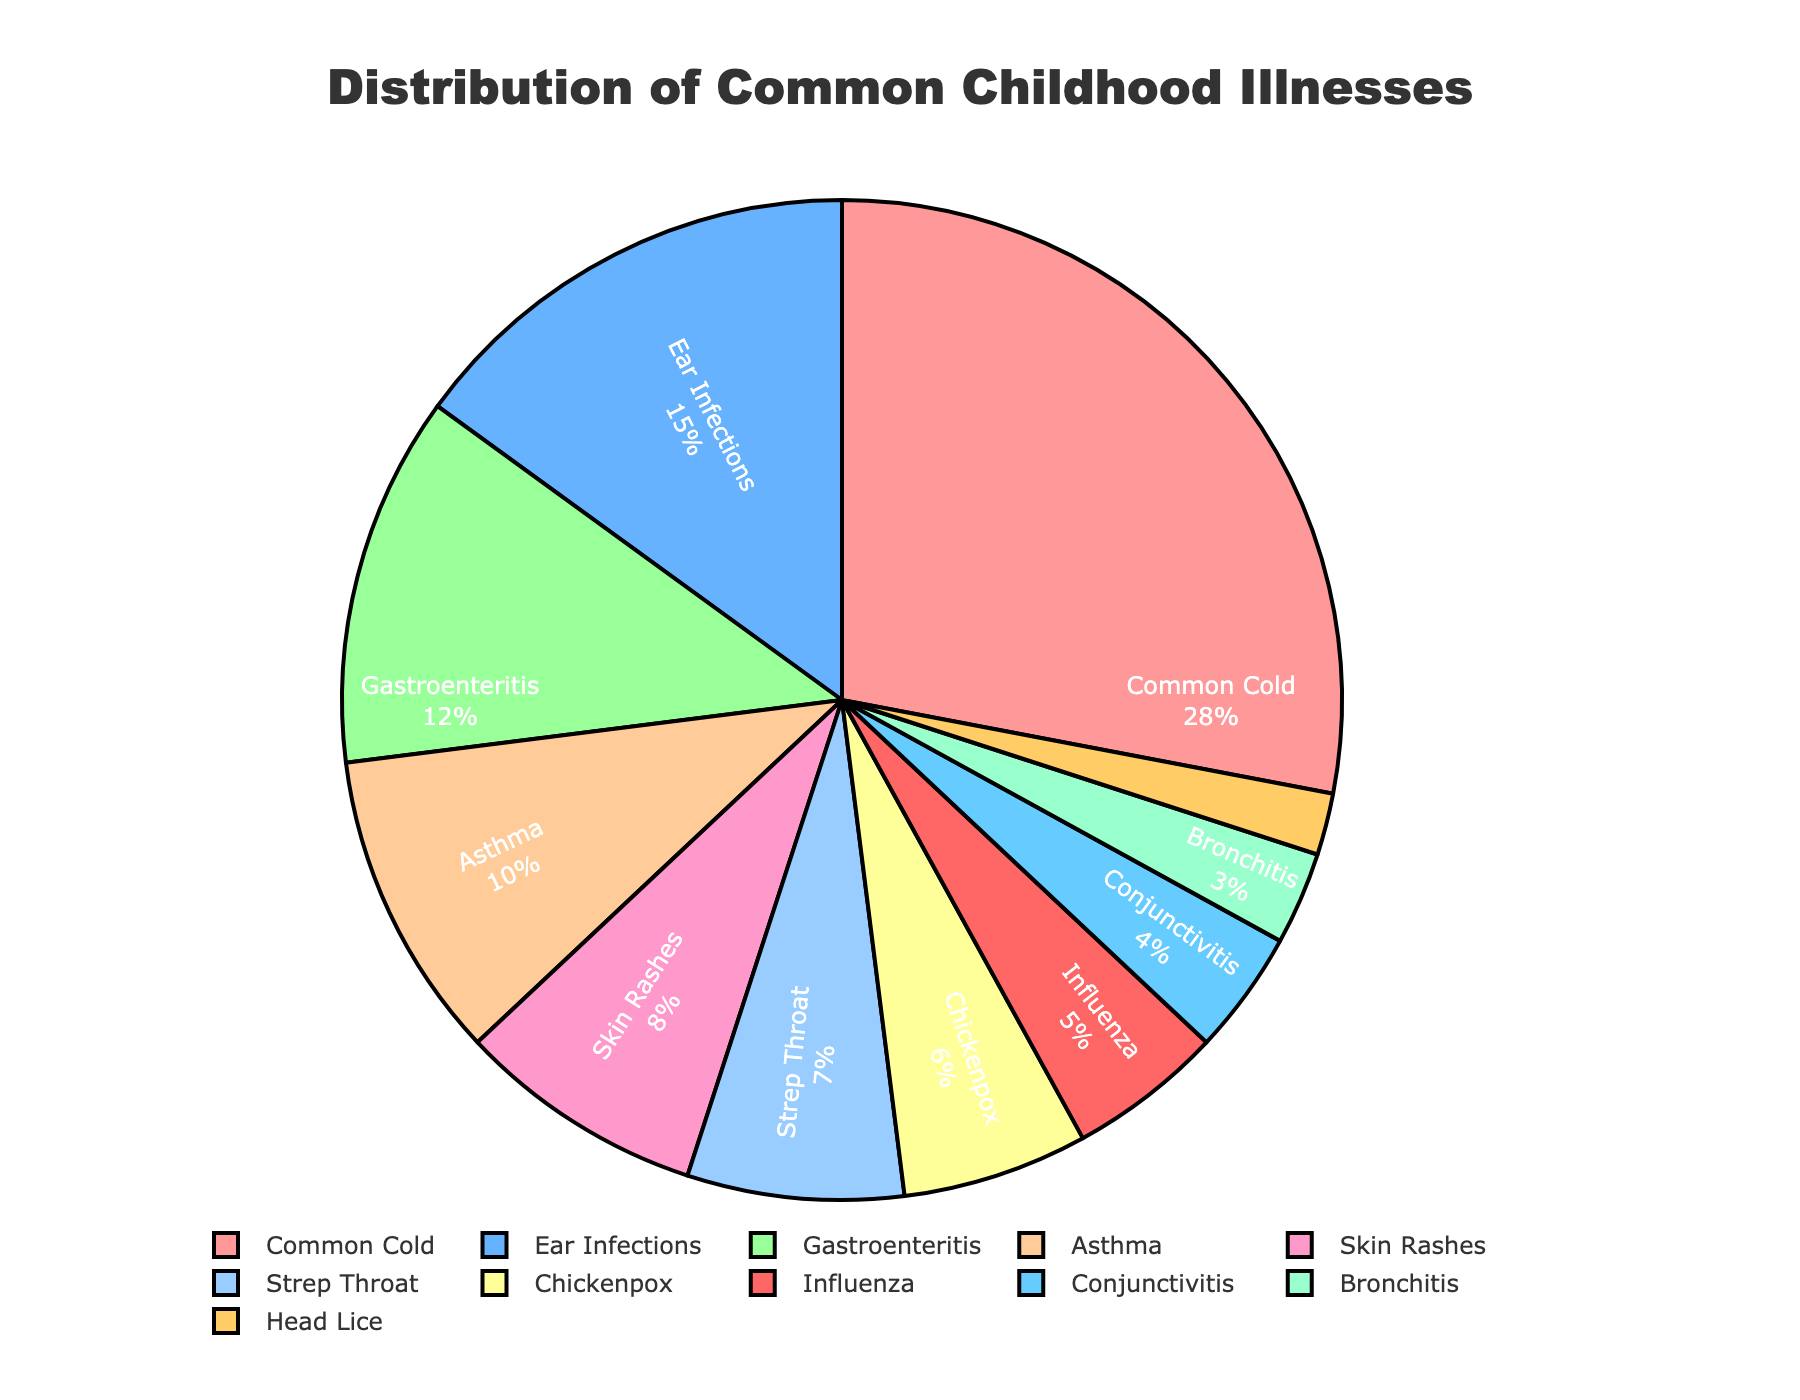what illness has the highest percentage? The figure shows that the "Common Cold" segment occupies the largest portion of the pie chart. This can be determined visually by comparing the sizes of the segments.
Answer: Common Cold Which illness is more common, Asthma or Chickenpox? By looking at the sizes of the segments labeled "Asthma" and "Chickenpox", the "Asthma" segment is larger than the "Chickenpox" segment.
Answer: Asthma What is the combined percentage of Gastroenteritis and Strep Throat? The figure shows the percentages for Gastroenteritis (12%) and Strep Throat (7%). Adding these percentages together gives 12% + 7% = 19%.
Answer: 19% Among the illnesses treated, which has the smallest percentage? The smallest segment on the pie chart corresponds to "Head Lice".
Answer: Head Lice How does the percentage of Influenza compare to that of Bronchitis? The figure shows that the percentage of Influenza (5%) is greater than that of Bronchitis (3%).
Answer: Influenza has a higher percentage What is the difference in percentage between Skin Rashes and Ear Infections? According to the figure, Skin Rashes account for 8% and Ear Infections for 15%. The difference is 15% - 8% = 7%.
Answer: 7% If you sum the percentages of Conjunctivitis, Bronchitis, and Head Lice, what do you get? The percentages are Conjunctivitis (4%), Bronchitis (3%), and Head Lice (2%). Summing them up: 4% + 3% + 2% = 9%.
Answer: 9% Which illness is represented by a green segment in the pie chart? The "Gastroenteritis" segment is colored green in the pie chart.
Answer: Gastroenteritis Are there more children treated for Ear Infections or for Strep Throat and Chickenpox combined? Ear Infections have a percentage of 15%. Strep Throat and Chickenpox combined have percentages of 7% and 6%, summing to 13%. 15% > 13%.
Answer: Ear Infections What is the average percentage for the illnesses with double-digit percentages? The illnesses with double-digit percentages are: Common Cold (28%), Ear Infections (15%), Gastroenteritis (12%), and Asthma (10%). The average is calculated as (28% + 15% + 12% + 10%) / 4 = 65% / 4 = 16.25%.
Answer: 16.25% 